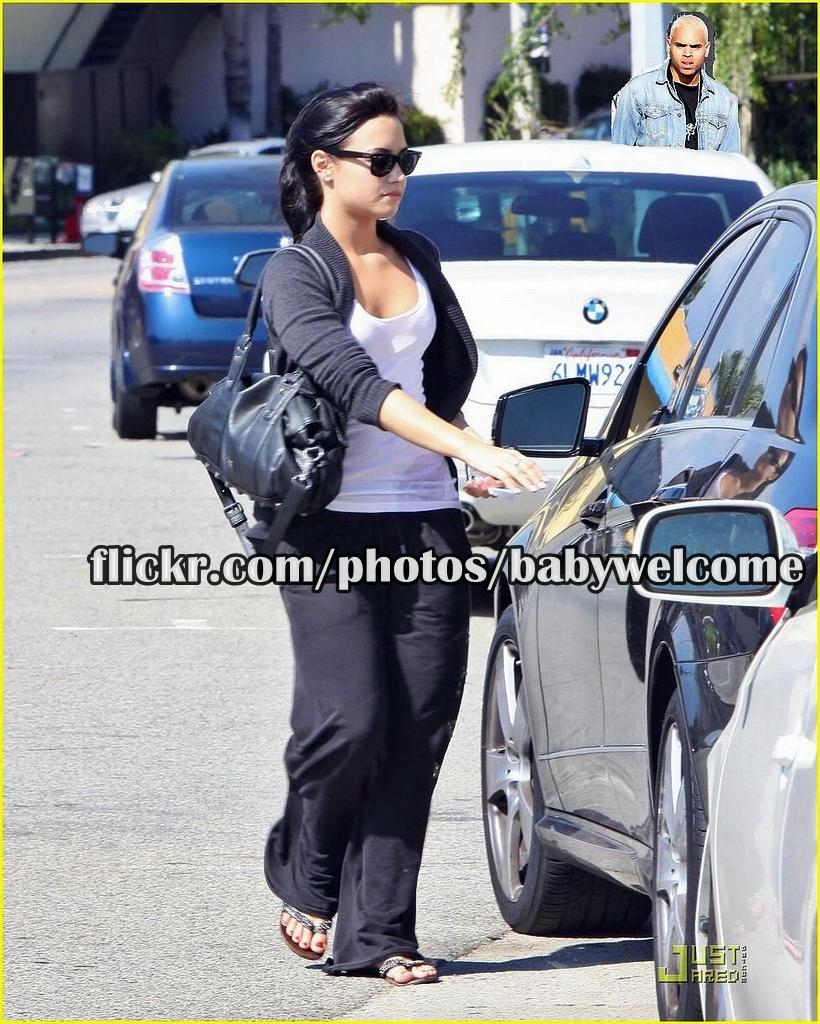What is the main subject of the image? The main subject of the image is cars on a road. What are the people in the image doing? People are standing on the road in the image. Can you describe the text in the image? There is some text in the middle of the image and some text on the bottom right of the image. What type of basin can be seen in the image? There is no basin present in the image. What memory is being triggered by the image? The image does not depict a specific memory, and it cannot trigger a memory for someone who is not present in the scene. 